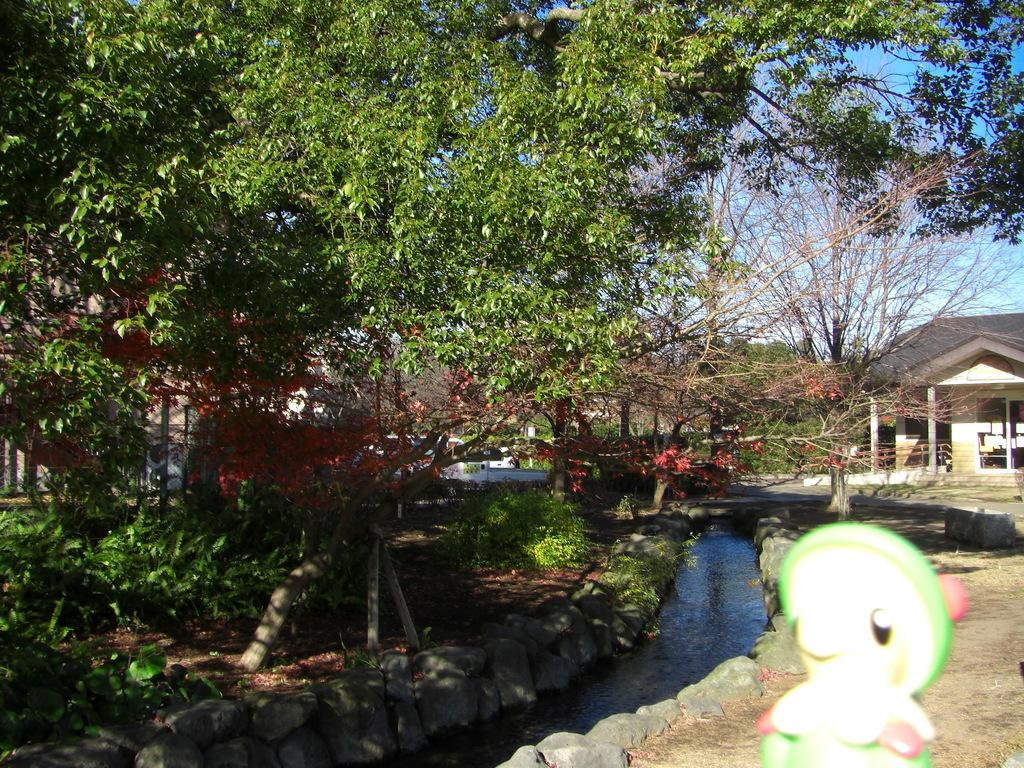What type of structures can be seen in the image? There are buildings in the image. What type of vegetation is present in the image? There are trees and bushes in the image. What is present on the ground in the image? Shredded leaves are present on the ground. What type of natural feature can be seen in the image? There is a canal in the image. What part of the environment is visible in the image? The sky is visible in the image. What can be observed in the sky in the image? Clouds are present in the sky. What type of pies are being sold at the north end of the canal in the image? There are no pies or indication of a location to sell them in the image. What sound can be heard coming from the canal in the image? The image is silent, so no sound can be heard. 